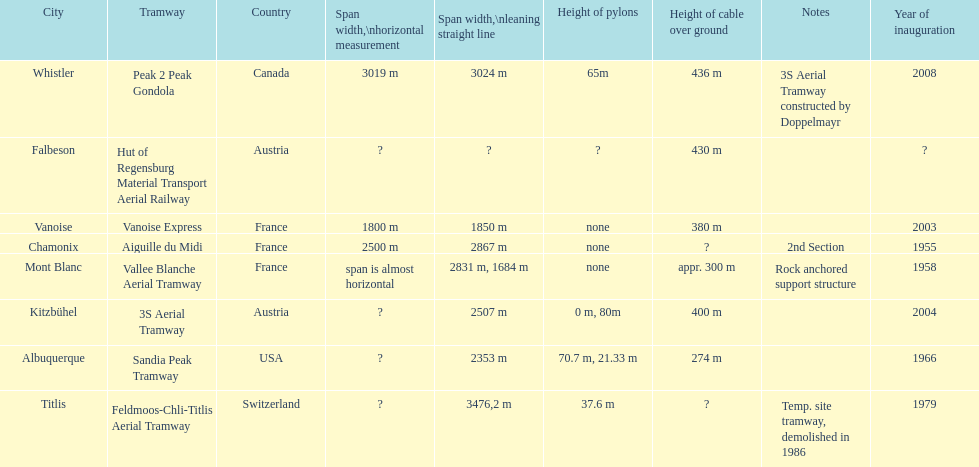How much longer is the peak 2 peak gondola than the 32 aerial tramway? 517. 